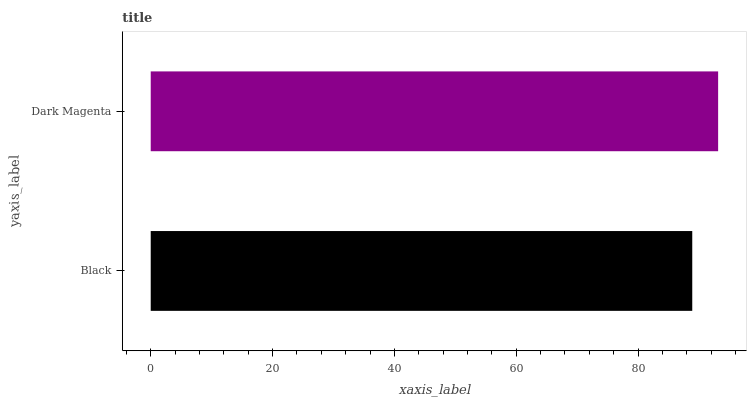Is Black the minimum?
Answer yes or no. Yes. Is Dark Magenta the maximum?
Answer yes or no. Yes. Is Dark Magenta the minimum?
Answer yes or no. No. Is Dark Magenta greater than Black?
Answer yes or no. Yes. Is Black less than Dark Magenta?
Answer yes or no. Yes. Is Black greater than Dark Magenta?
Answer yes or no. No. Is Dark Magenta less than Black?
Answer yes or no. No. Is Dark Magenta the high median?
Answer yes or no. Yes. Is Black the low median?
Answer yes or no. Yes. Is Black the high median?
Answer yes or no. No. Is Dark Magenta the low median?
Answer yes or no. No. 